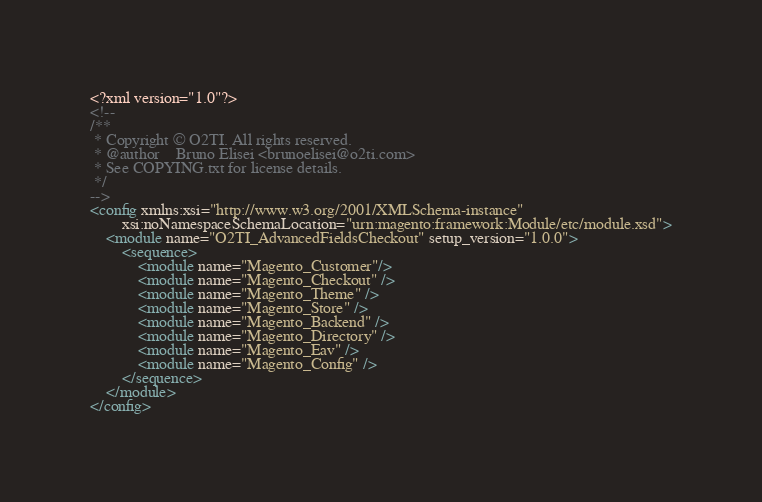Convert code to text. <code><loc_0><loc_0><loc_500><loc_500><_XML_><?xml version="1.0"?>
<!--
/**
 * Copyright © O2TI. All rights reserved.
 * @author    Bruno Elisei <brunoelisei@o2ti.com>
 * See COPYING.txt for license details.
 */
-->
<config xmlns:xsi="http://www.w3.org/2001/XMLSchema-instance"
        xsi:noNamespaceSchemaLocation="urn:magento:framework:Module/etc/module.xsd">
    <module name="O2TI_AdvancedFieldsCheckout" setup_version="1.0.0">
        <sequence>
            <module name="Magento_Customer"/>
            <module name="Magento_Checkout" />
            <module name="Magento_Theme" />
            <module name="Magento_Store" />
            <module name="Magento_Backend" />
            <module name="Magento_Directory" />
            <module name="Magento_Eav" />
            <module name="Magento_Config" />
        </sequence>
    </module>
</config>
</code> 